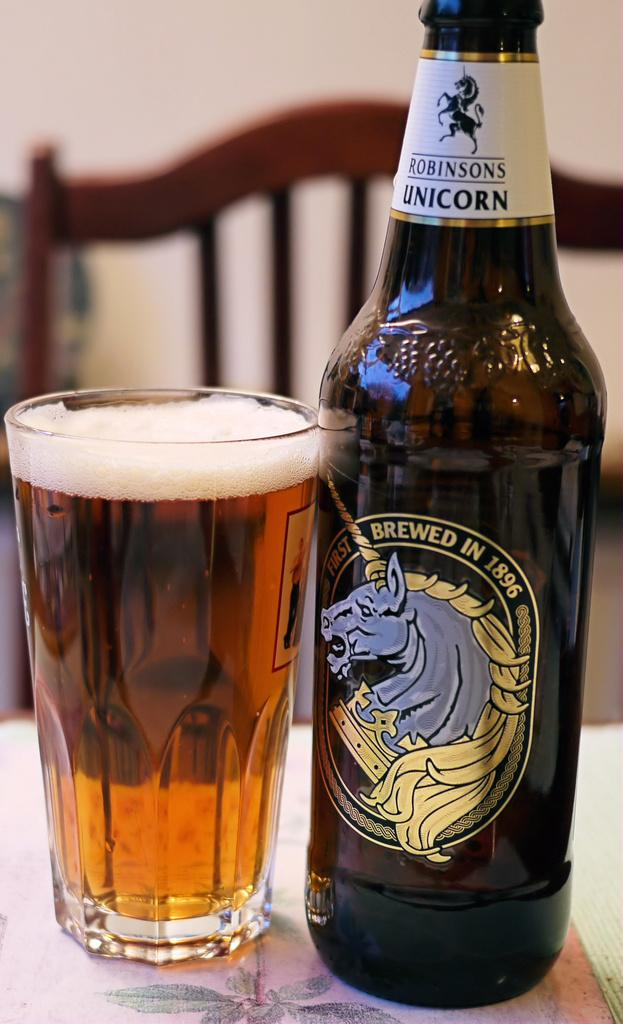Provide a one-sentence caption for the provided image. A glass and beer bottle from Robinsons Unicorn. 